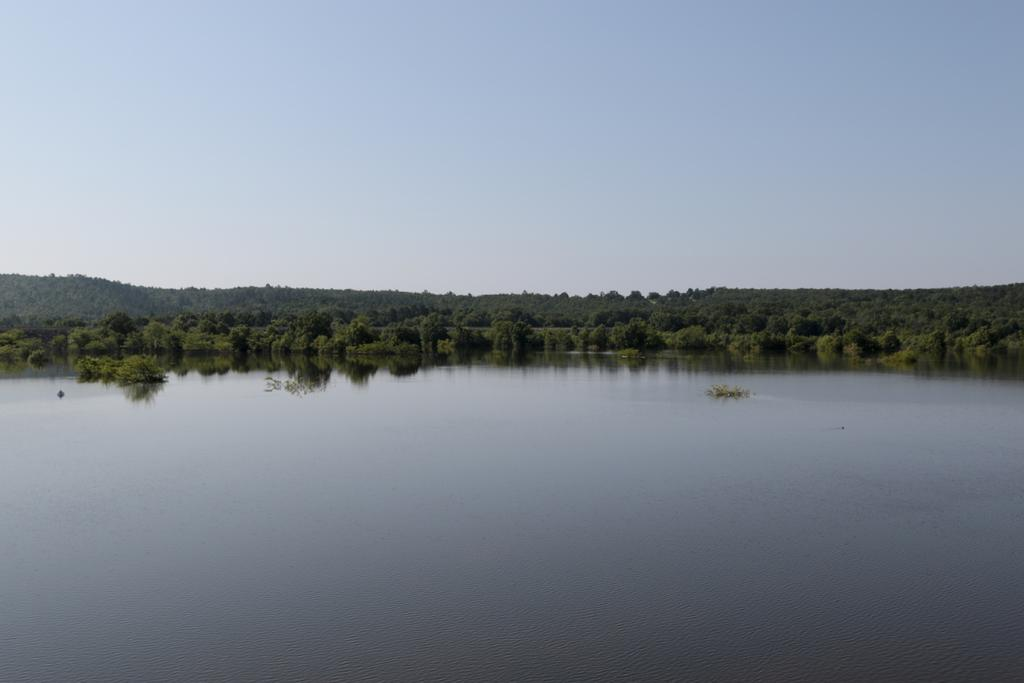What type of natural body of water is present in the image? There is a lake in the image. What type of vegetation can be seen in the image? There are trees in the image. What part of the natural environment is visible in the image? The sky is visible in the image. Can you see any love letters being read by someone near the lake in the image? There is no mention of love letters or anyone reading them in the image. 